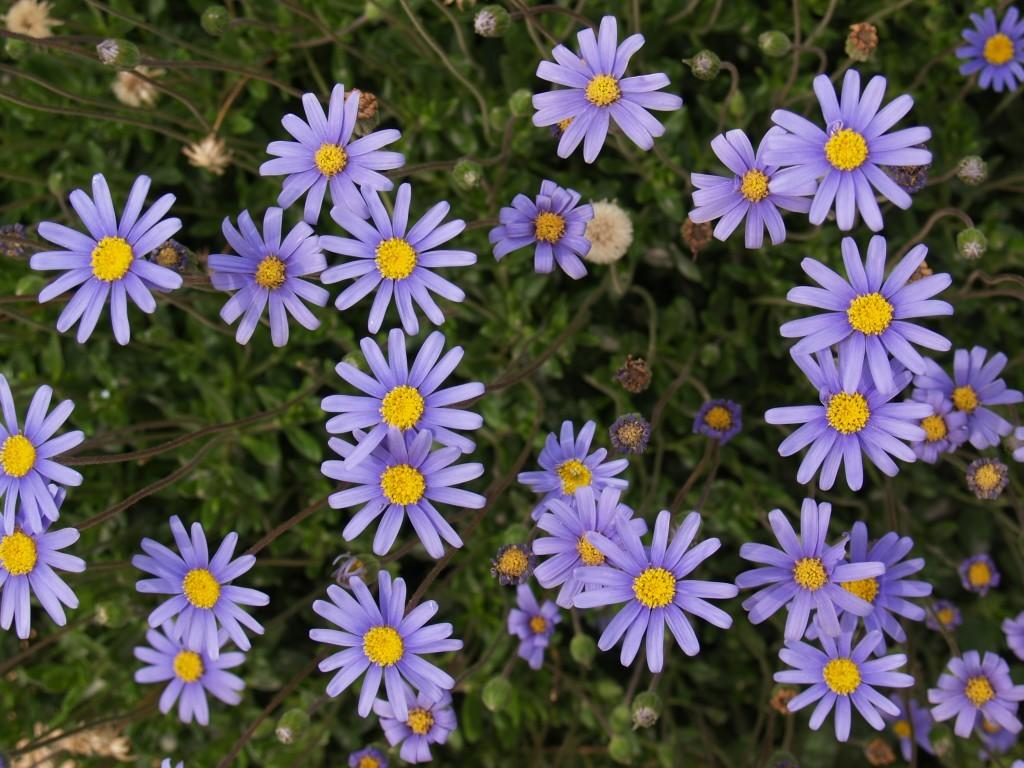What type of flora is present in the image? There are flowers in the image. What colors can be seen in the flowers? The flowers are in purple and yellow colors. What color are the plants that the flowers are growing on? The plants are in green color. How many people are in the crowd surrounding the flowers in the image? There is no crowd present in the image; it only features flowers and plants. 